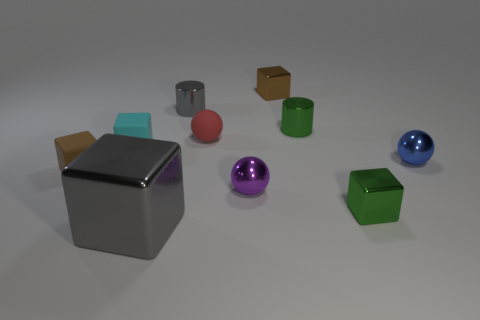Subtract all gray cylinders. How many cylinders are left? 1 Subtract all metal balls. How many balls are left? 1 Subtract 1 blocks. How many blocks are left? 4 Subtract all balls. How many objects are left? 7 Subtract all gray balls. How many green blocks are left? 1 Subtract 1 green cylinders. How many objects are left? 9 Subtract all brown blocks. Subtract all red balls. How many blocks are left? 3 Subtract all brown matte cubes. Subtract all small blue objects. How many objects are left? 8 Add 4 small cyan cubes. How many small cyan cubes are left? 5 Add 2 large green shiny spheres. How many large green shiny spheres exist? 2 